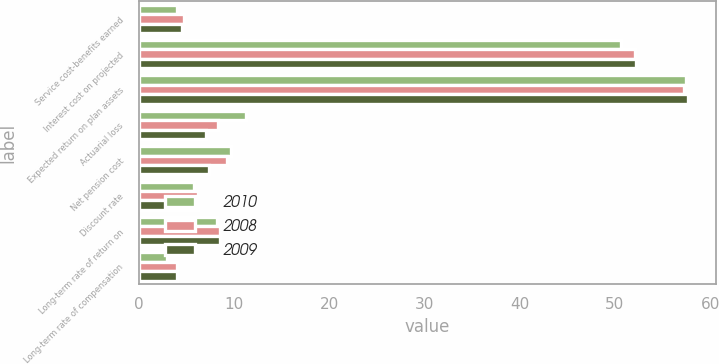Convert chart. <chart><loc_0><loc_0><loc_500><loc_500><stacked_bar_chart><ecel><fcel>Service cost-benefits earned<fcel>Interest cost on projected<fcel>Expected return on plan assets<fcel>Actuarial loss<fcel>Net pension cost<fcel>Discount rate<fcel>Long-term rate of return on<fcel>Long-term rate of compensation<nl><fcel>2010<fcel>4<fcel>50.6<fcel>57.5<fcel>11.3<fcel>9.7<fcel>5.75<fcel>8.25<fcel>3<nl><fcel>2008<fcel>4.8<fcel>52.1<fcel>57.2<fcel>8.3<fcel>9.3<fcel>6.25<fcel>8.5<fcel>4<nl><fcel>2009<fcel>4.5<fcel>52.2<fcel>57.7<fcel>7.1<fcel>7.4<fcel>6.25<fcel>8.5<fcel>4<nl></chart> 